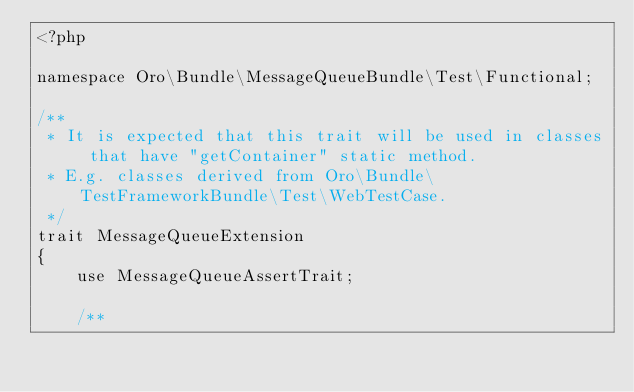Convert code to text. <code><loc_0><loc_0><loc_500><loc_500><_PHP_><?php

namespace Oro\Bundle\MessageQueueBundle\Test\Functional;

/**
 * It is expected that this trait will be used in classes that have "getContainer" static method.
 * E.g. classes derived from Oro\Bundle\TestFrameworkBundle\Test\WebTestCase.
 */
trait MessageQueueExtension
{
    use MessageQueueAssertTrait;

    /**</code> 